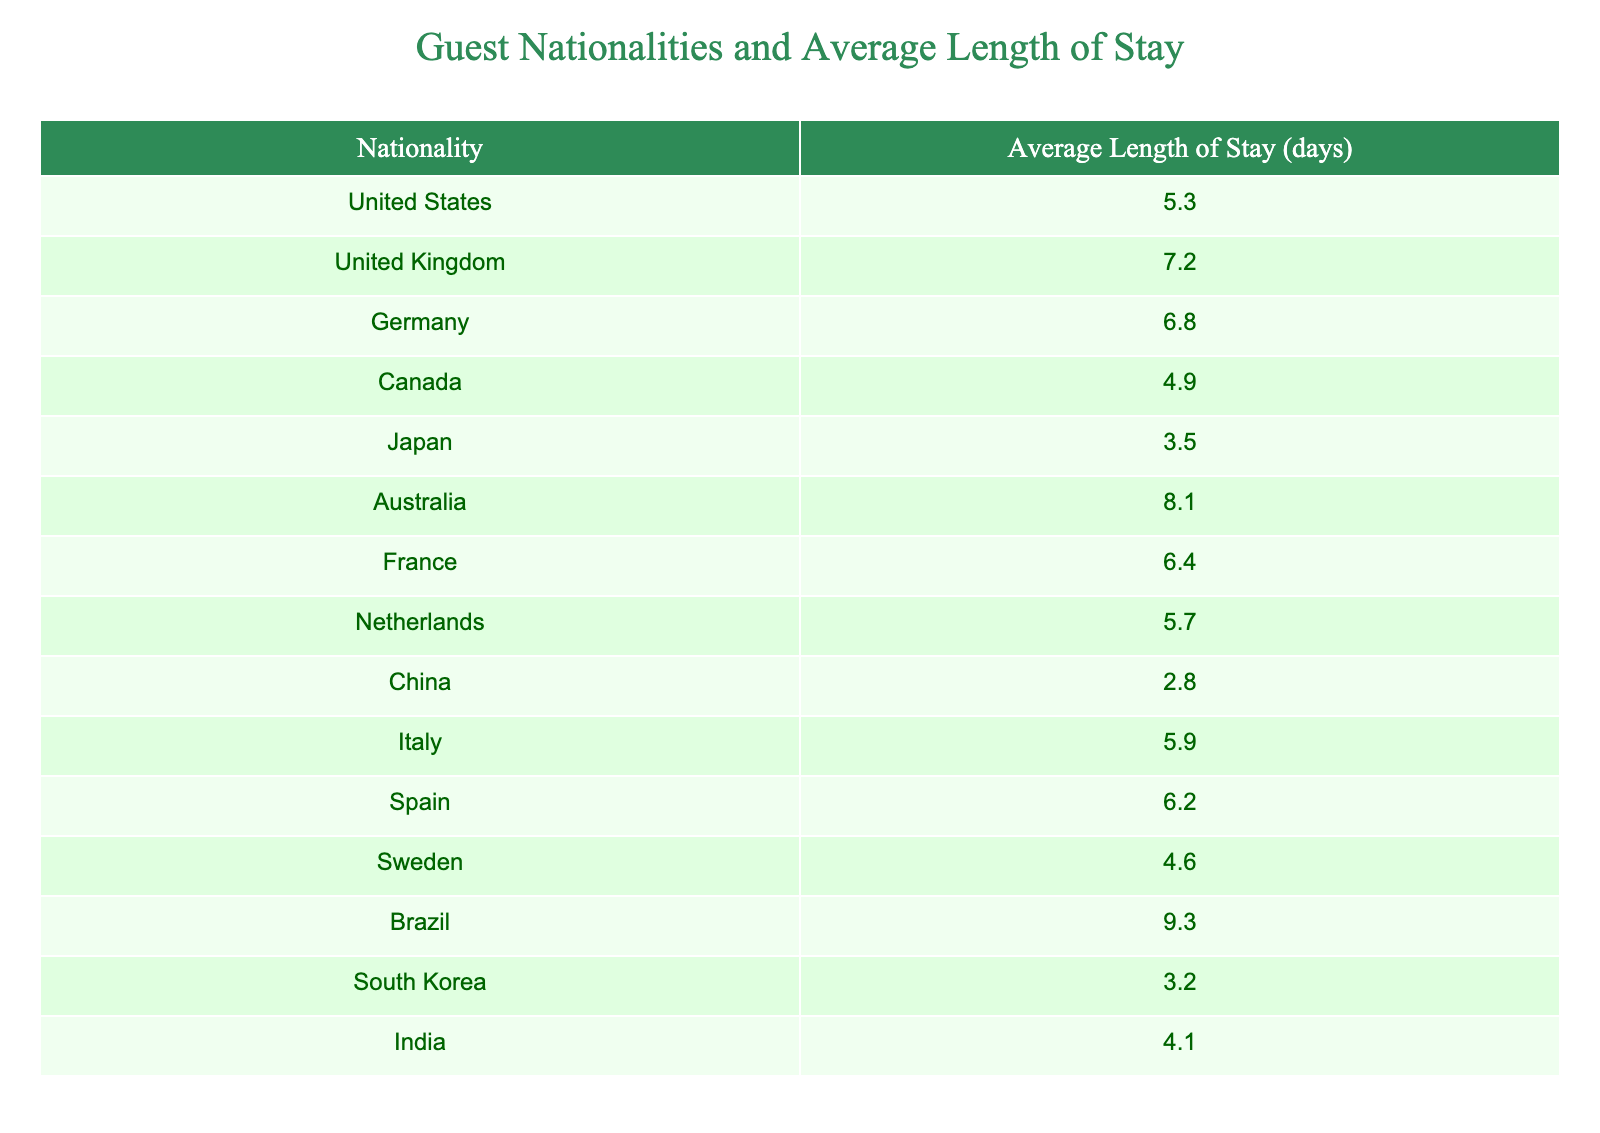What is the average length of stay for guests from the United States? The table shows that the average length of stay for guests from the United States is directly listed as 5.3 days.
Answer: 5.3 days Which nationality has the longest average length of stay? By examining the lengths of stay, Brazil has the highest value listed at 9.3 days.
Answer: Brazil How does the average length of stay for guests from Japan compare to that of guests from Canada? Japan has an average length of stay of 3.5 days, while Canada has 4.9 days. Since 4.9 is greater than 3.5, guests from Canada stay longer on average than those from Japan.
Answer: Guests from Canada stay longer What is the average length of stay for guests from European countries? The European countries listed are the United Kingdom, Germany, France, Netherlands, Italy, Spain, and Sweden. Their average lengths of stay are 7.2, 6.8, 6.4, 5.7, 5.9, 6.2, and 4.6 days respectively. Calculating the average: (7.2 + 6.8 + 6.4 + 5.7 + 5.9 + 6.2 + 4.6) = 43.8 days for 7 countries, so the average is 43.8/7 = 6.26 days.
Answer: 6.26 days Is the average length of stay for guests from South Korea greater than that of guests from China? South Korea has an average stay of 3.2 days while China has 2.8 days. Since 3.2 is greater than 2.8, the statement is true.
Answer: Yes What is the total average length of stay for the three nationalities with the shortest average stays? The three shortest stays are from China (2.8), South Korea (3.2), and Japan (3.5). Their sum is 2.8 + 3.2 + 3.5 = 9.5 days. The average is 9.5/3 = 3.17 days.
Answer: 3.17 days Which nationality has a shorter average length of stay: France or Germany? France has an average stay of 6.4 days, while Germany has 6.8 days. The value for France is less than that of Germany, meaning guests from France stay shorter on average.
Answer: France What is the difference in average length of stay between guests from Australia and those from Brazil? Guests from Australia stay for an average of 8.1 days, while guests from Brazil stay for 9.3 days. The difference is 9.3 - 8.1 = 1.2 days, meaning Brazilian guests stay longer by this amount.
Answer: 1.2 days Which nationality among the ones listed has an average stay of exactly 5.9 days? The only nationality listed with an average stay of exactly 5.9 days is Italy, which is directly visible in the table.
Answer: Italy 